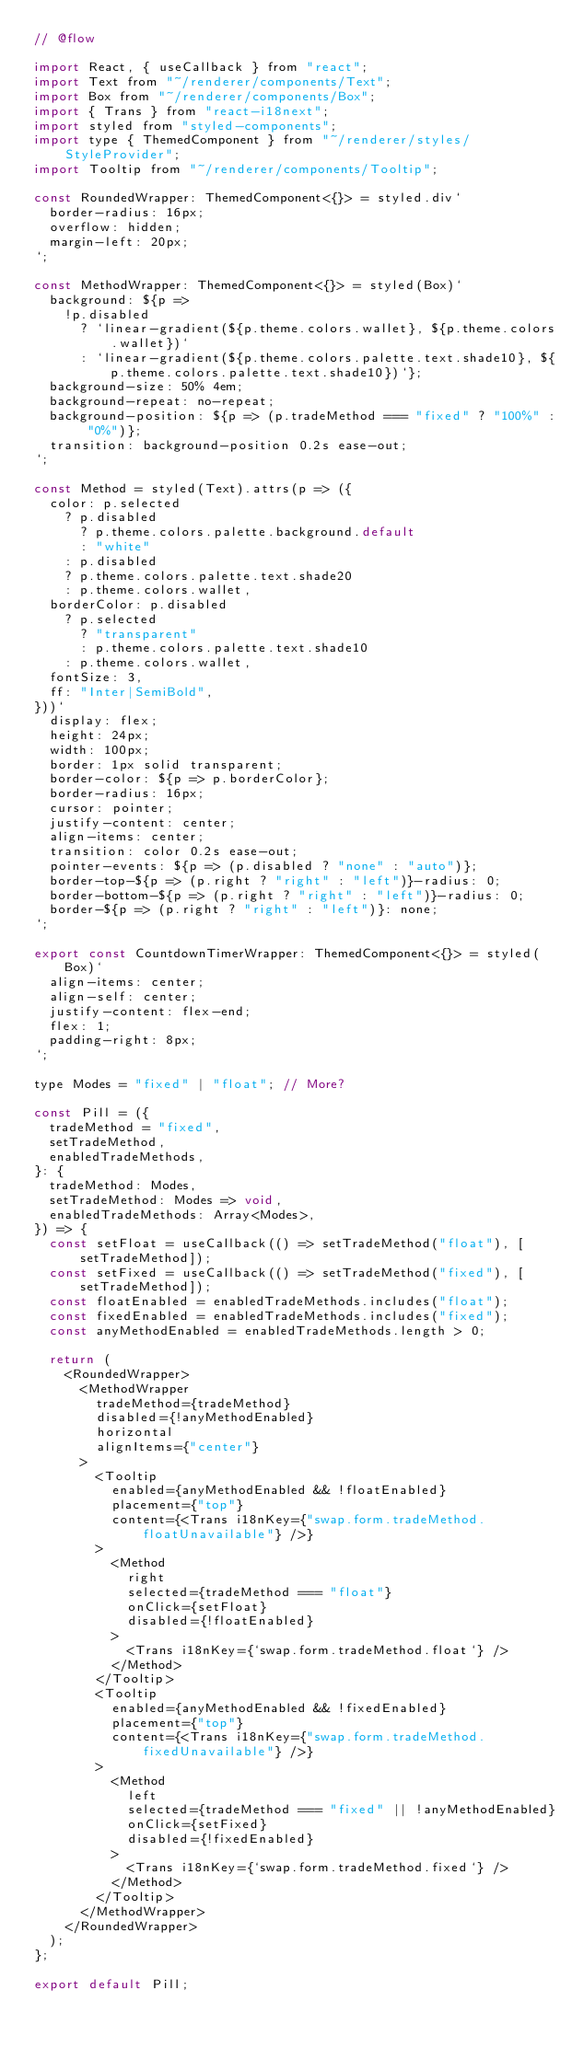<code> <loc_0><loc_0><loc_500><loc_500><_JavaScript_>// @flow

import React, { useCallback } from "react";
import Text from "~/renderer/components/Text";
import Box from "~/renderer/components/Box";
import { Trans } from "react-i18next";
import styled from "styled-components";
import type { ThemedComponent } from "~/renderer/styles/StyleProvider";
import Tooltip from "~/renderer/components/Tooltip";

const RoundedWrapper: ThemedComponent<{}> = styled.div`
  border-radius: 16px;
  overflow: hidden;
  margin-left: 20px;
`;

const MethodWrapper: ThemedComponent<{}> = styled(Box)`
  background: ${p =>
    !p.disabled
      ? `linear-gradient(${p.theme.colors.wallet}, ${p.theme.colors.wallet})`
      : `linear-gradient(${p.theme.colors.palette.text.shade10}, ${p.theme.colors.palette.text.shade10})`};
  background-size: 50% 4em;
  background-repeat: no-repeat;
  background-position: ${p => (p.tradeMethod === "fixed" ? "100%" : "0%")};
  transition: background-position 0.2s ease-out;
`;

const Method = styled(Text).attrs(p => ({
  color: p.selected
    ? p.disabled
      ? p.theme.colors.palette.background.default
      : "white"
    : p.disabled
    ? p.theme.colors.palette.text.shade20
    : p.theme.colors.wallet,
  borderColor: p.disabled
    ? p.selected
      ? "transparent"
      : p.theme.colors.palette.text.shade10
    : p.theme.colors.wallet,
  fontSize: 3,
  ff: "Inter|SemiBold",
}))`
  display: flex;
  height: 24px;
  width: 100px;
  border: 1px solid transparent;
  border-color: ${p => p.borderColor};
  border-radius: 16px;
  cursor: pointer;
  justify-content: center;
  align-items: center;
  transition: color 0.2s ease-out;
  pointer-events: ${p => (p.disabled ? "none" : "auto")};
  border-top-${p => (p.right ? "right" : "left")}-radius: 0;
  border-bottom-${p => (p.right ? "right" : "left")}-radius: 0;
  border-${p => (p.right ? "right" : "left")}: none;
`;

export const CountdownTimerWrapper: ThemedComponent<{}> = styled(Box)`
  align-items: center;
  align-self: center;
  justify-content: flex-end;
  flex: 1;
  padding-right: 8px;
`;

type Modes = "fixed" | "float"; // More?

const Pill = ({
  tradeMethod = "fixed",
  setTradeMethod,
  enabledTradeMethods,
}: {
  tradeMethod: Modes,
  setTradeMethod: Modes => void,
  enabledTradeMethods: Array<Modes>,
}) => {
  const setFloat = useCallback(() => setTradeMethod("float"), [setTradeMethod]);
  const setFixed = useCallback(() => setTradeMethod("fixed"), [setTradeMethod]);
  const floatEnabled = enabledTradeMethods.includes("float");
  const fixedEnabled = enabledTradeMethods.includes("fixed");
  const anyMethodEnabled = enabledTradeMethods.length > 0;

  return (
    <RoundedWrapper>
      <MethodWrapper
        tradeMethod={tradeMethod}
        disabled={!anyMethodEnabled}
        horizontal
        alignItems={"center"}
      >
        <Tooltip
          enabled={anyMethodEnabled && !floatEnabled}
          placement={"top"}
          content={<Trans i18nKey={"swap.form.tradeMethod.floatUnavailable"} />}
        >
          <Method
            right
            selected={tradeMethod === "float"}
            onClick={setFloat}
            disabled={!floatEnabled}
          >
            <Trans i18nKey={`swap.form.tradeMethod.float`} />
          </Method>
        </Tooltip>
        <Tooltip
          enabled={anyMethodEnabled && !fixedEnabled}
          placement={"top"}
          content={<Trans i18nKey={"swap.form.tradeMethod.fixedUnavailable"} />}
        >
          <Method
            left
            selected={tradeMethod === "fixed" || !anyMethodEnabled}
            onClick={setFixed}
            disabled={!fixedEnabled}
          >
            <Trans i18nKey={`swap.form.tradeMethod.fixed`} />
          </Method>
        </Tooltip>
      </MethodWrapper>
    </RoundedWrapper>
  );
};

export default Pill;
</code> 